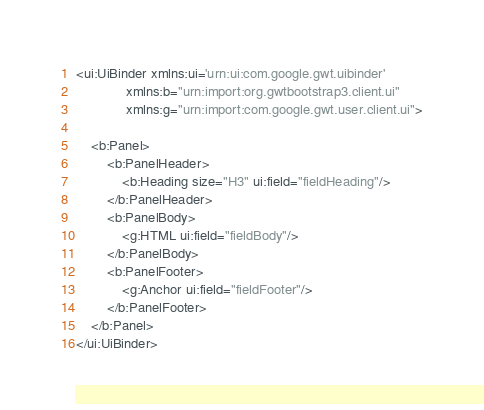Convert code to text. <code><loc_0><loc_0><loc_500><loc_500><_XML_><ui:UiBinder xmlns:ui='urn:ui:com.google.gwt.uibinder'
             xmlns:b="urn:import:org.gwtbootstrap3.client.ui"
             xmlns:g="urn:import:com.google.gwt.user.client.ui">

    <b:Panel>
        <b:PanelHeader>
            <b:Heading size="H3" ui:field="fieldHeading"/>
        </b:PanelHeader>
        <b:PanelBody>
            <g:HTML ui:field="fieldBody"/>
        </b:PanelBody>
        <b:PanelFooter>
            <g:Anchor ui:field="fieldFooter"/>
        </b:PanelFooter>
    </b:Panel>
</ui:UiBinder></code> 